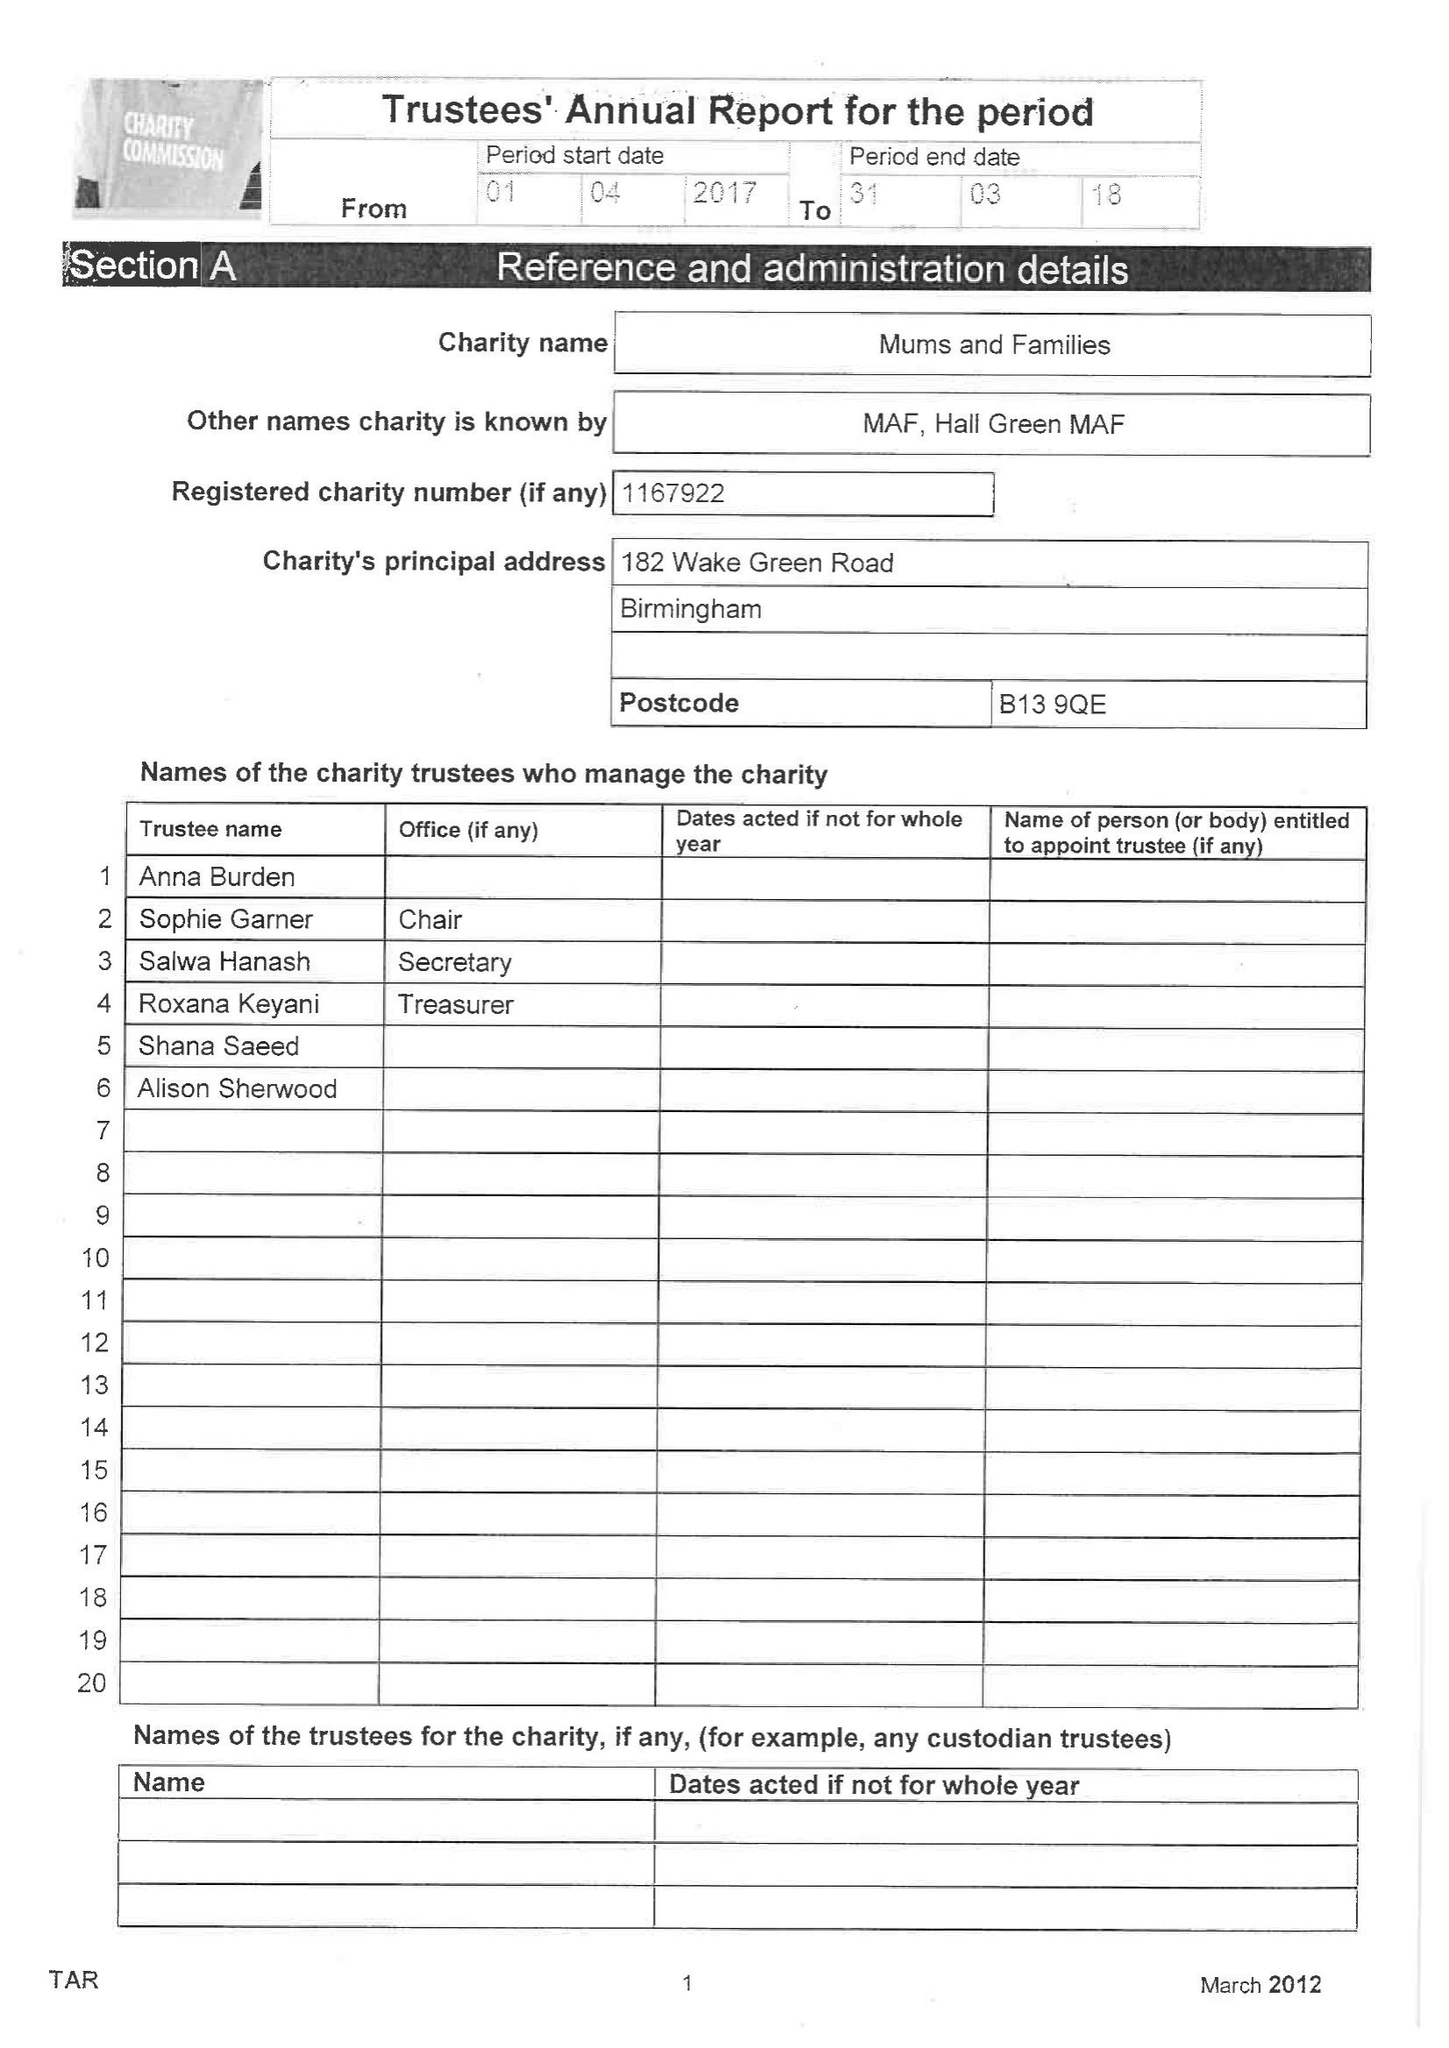What is the value for the address__post_town?
Answer the question using a single word or phrase. BIRMINGHAM 